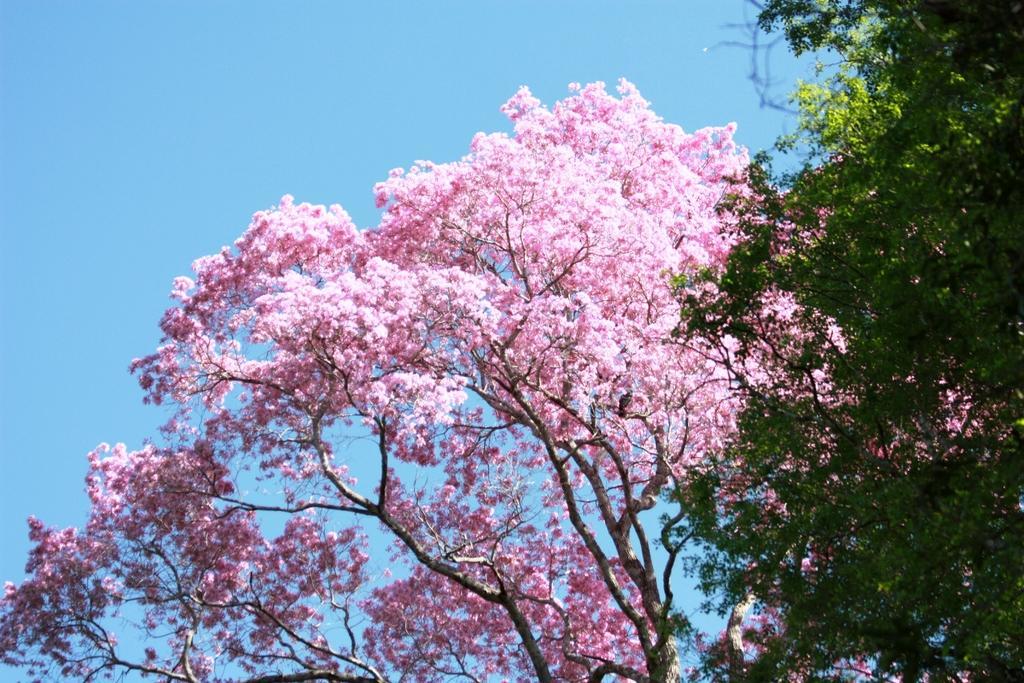Can you describe this image briefly? In this image we can see blossoms and sky in the background. 